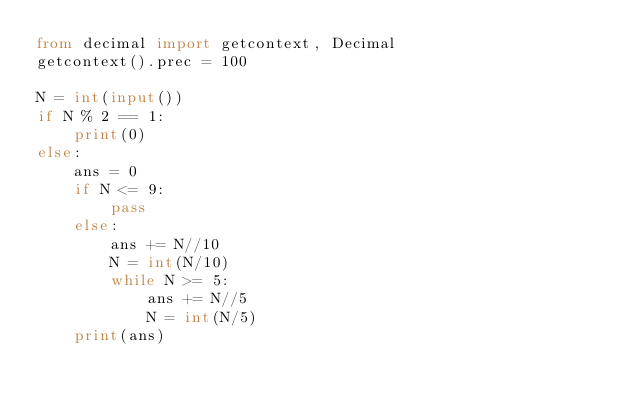Convert code to text. <code><loc_0><loc_0><loc_500><loc_500><_Python_>from decimal import getcontext, Decimal
getcontext().prec = 100

N = int(input())
if N % 2 == 1:
	print(0)
else:
	ans = 0
	if N <= 9:
		pass
	else:
		ans += N//10
		N = int(N/10)
		while N >= 5:
			ans += N//5
			N = int(N/5)
	print(ans)</code> 